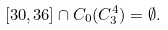Convert formula to latex. <formula><loc_0><loc_0><loc_500><loc_500>[ 3 0 , 3 6 ] \cap C _ { 0 } ( C _ { 3 } ^ { 4 } ) = \emptyset .</formula> 